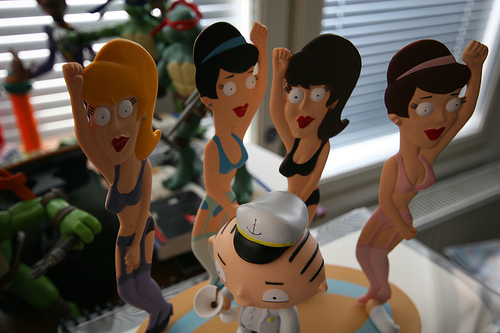<image>
Is the turtle behind the woman? Yes. From this viewpoint, the turtle is positioned behind the woman, with the woman partially or fully occluding the turtle. Is the toy on the window? No. The toy is not positioned on the window. They may be near each other, but the toy is not supported by or resting on top of the window. Is there a hat on the girl? No. The hat is not positioned on the girl. They may be near each other, but the hat is not supported by or resting on top of the girl. Where is the ninja turtle in relation to the woman? Is it in front of the woman? No. The ninja turtle is not in front of the woman. The spatial positioning shows a different relationship between these objects. 